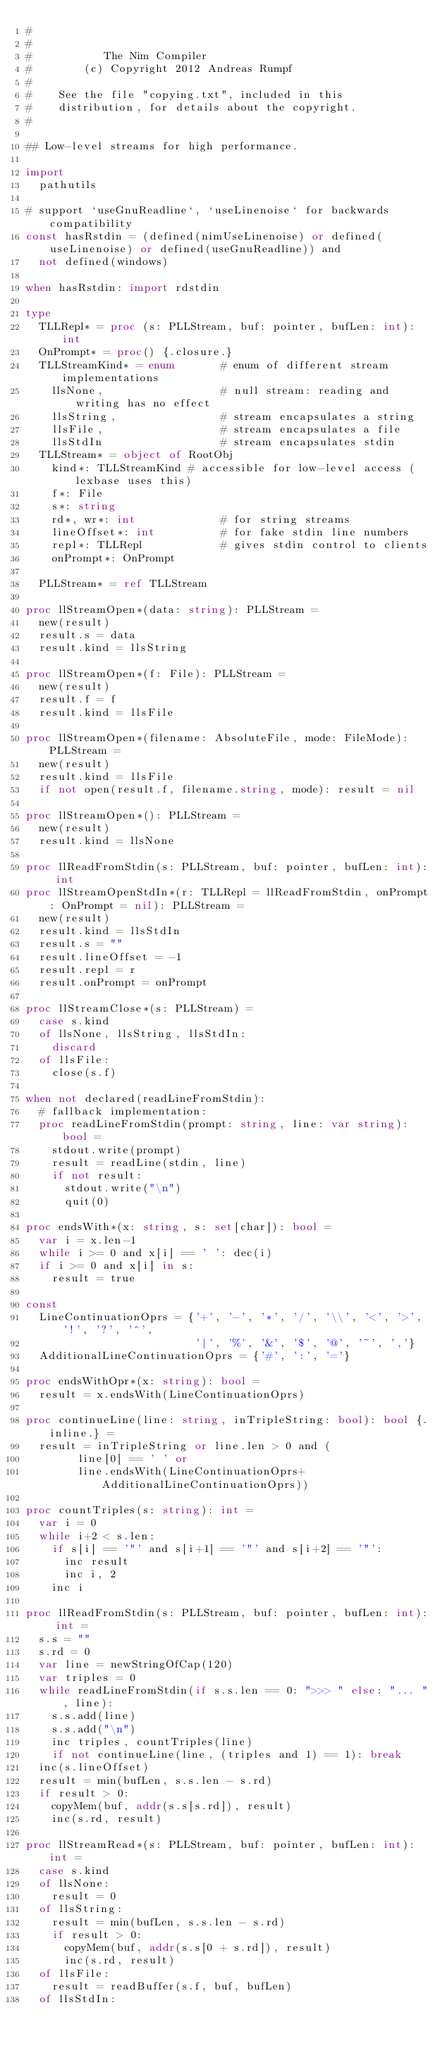<code> <loc_0><loc_0><loc_500><loc_500><_Nim_>#
#
#           The Nim Compiler
#        (c) Copyright 2012 Andreas Rumpf
#
#    See the file "copying.txt", included in this
#    distribution, for details about the copyright.
#

## Low-level streams for high performance.

import
  pathutils

# support `useGnuReadline`, `useLinenoise` for backwards compatibility
const hasRstdin = (defined(nimUseLinenoise) or defined(useLinenoise) or defined(useGnuReadline)) and
  not defined(windows)

when hasRstdin: import rdstdin

type
  TLLRepl* = proc (s: PLLStream, buf: pointer, bufLen: int): int
  OnPrompt* = proc() {.closure.}
  TLLStreamKind* = enum       # enum of different stream implementations
    llsNone,                  # null stream: reading and writing has no effect
    llsString,                # stream encapsulates a string
    llsFile,                  # stream encapsulates a file
    llsStdIn                  # stream encapsulates stdin
  TLLStream* = object of RootObj
    kind*: TLLStreamKind # accessible for low-level access (lexbase uses this)
    f*: File
    s*: string
    rd*, wr*: int             # for string streams
    lineOffset*: int          # for fake stdin line numbers
    repl*: TLLRepl            # gives stdin control to clients
    onPrompt*: OnPrompt

  PLLStream* = ref TLLStream

proc llStreamOpen*(data: string): PLLStream =
  new(result)
  result.s = data
  result.kind = llsString

proc llStreamOpen*(f: File): PLLStream =
  new(result)
  result.f = f
  result.kind = llsFile

proc llStreamOpen*(filename: AbsoluteFile, mode: FileMode): PLLStream =
  new(result)
  result.kind = llsFile
  if not open(result.f, filename.string, mode): result = nil

proc llStreamOpen*(): PLLStream =
  new(result)
  result.kind = llsNone

proc llReadFromStdin(s: PLLStream, buf: pointer, bufLen: int): int
proc llStreamOpenStdIn*(r: TLLRepl = llReadFromStdin, onPrompt: OnPrompt = nil): PLLStream =
  new(result)
  result.kind = llsStdIn
  result.s = ""
  result.lineOffset = -1
  result.repl = r
  result.onPrompt = onPrompt

proc llStreamClose*(s: PLLStream) =
  case s.kind
  of llsNone, llsString, llsStdIn:
    discard
  of llsFile:
    close(s.f)

when not declared(readLineFromStdin):
  # fallback implementation:
  proc readLineFromStdin(prompt: string, line: var string): bool =
    stdout.write(prompt)
    result = readLine(stdin, line)
    if not result:
      stdout.write("\n")
      quit(0)

proc endsWith*(x: string, s: set[char]): bool =
  var i = x.len-1
  while i >= 0 and x[i] == ' ': dec(i)
  if i >= 0 and x[i] in s:
    result = true

const
  LineContinuationOprs = {'+', '-', '*', '/', '\\', '<', '>', '!', '?', '^',
                          '|', '%', '&', '$', '@', '~', ','}
  AdditionalLineContinuationOprs = {'#', ':', '='}

proc endsWithOpr*(x: string): bool =
  result = x.endsWith(LineContinuationOprs)

proc continueLine(line: string, inTripleString: bool): bool {.inline.} =
  result = inTripleString or line.len > 0 and (
        line[0] == ' ' or
        line.endsWith(LineContinuationOprs+AdditionalLineContinuationOprs))

proc countTriples(s: string): int =
  var i = 0
  while i+2 < s.len:
    if s[i] == '"' and s[i+1] == '"' and s[i+2] == '"':
      inc result
      inc i, 2
    inc i

proc llReadFromStdin(s: PLLStream, buf: pointer, bufLen: int): int =
  s.s = ""
  s.rd = 0
  var line = newStringOfCap(120)
  var triples = 0
  while readLineFromStdin(if s.s.len == 0: ">>> " else: "... ", line):
    s.s.add(line)
    s.s.add("\n")
    inc triples, countTriples(line)
    if not continueLine(line, (triples and 1) == 1): break
  inc(s.lineOffset)
  result = min(bufLen, s.s.len - s.rd)
  if result > 0:
    copyMem(buf, addr(s.s[s.rd]), result)
    inc(s.rd, result)

proc llStreamRead*(s: PLLStream, buf: pointer, bufLen: int): int =
  case s.kind
  of llsNone:
    result = 0
  of llsString:
    result = min(bufLen, s.s.len - s.rd)
    if result > 0:
      copyMem(buf, addr(s.s[0 + s.rd]), result)
      inc(s.rd, result)
  of llsFile:
    result = readBuffer(s.f, buf, bufLen)
  of llsStdIn:</code> 